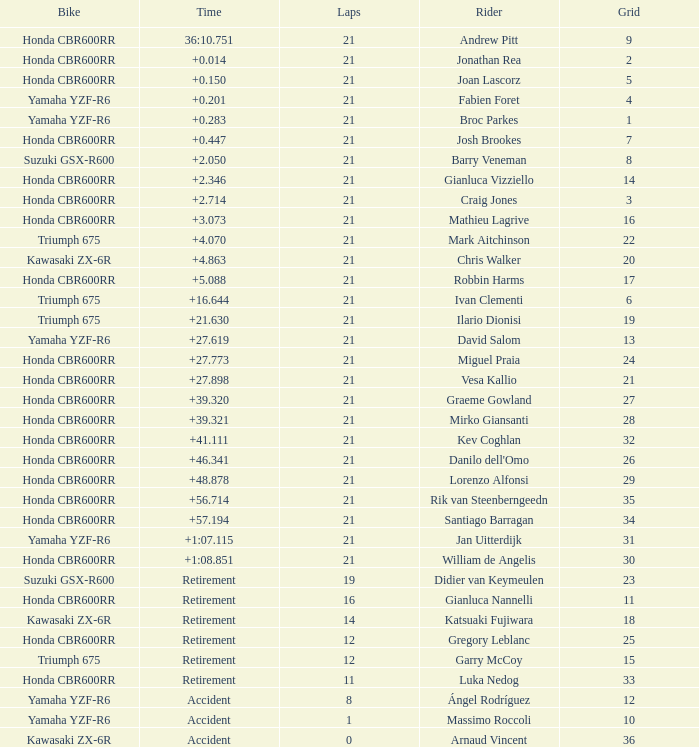What driver had the highest grid position with a time of +0.283? 1.0. 